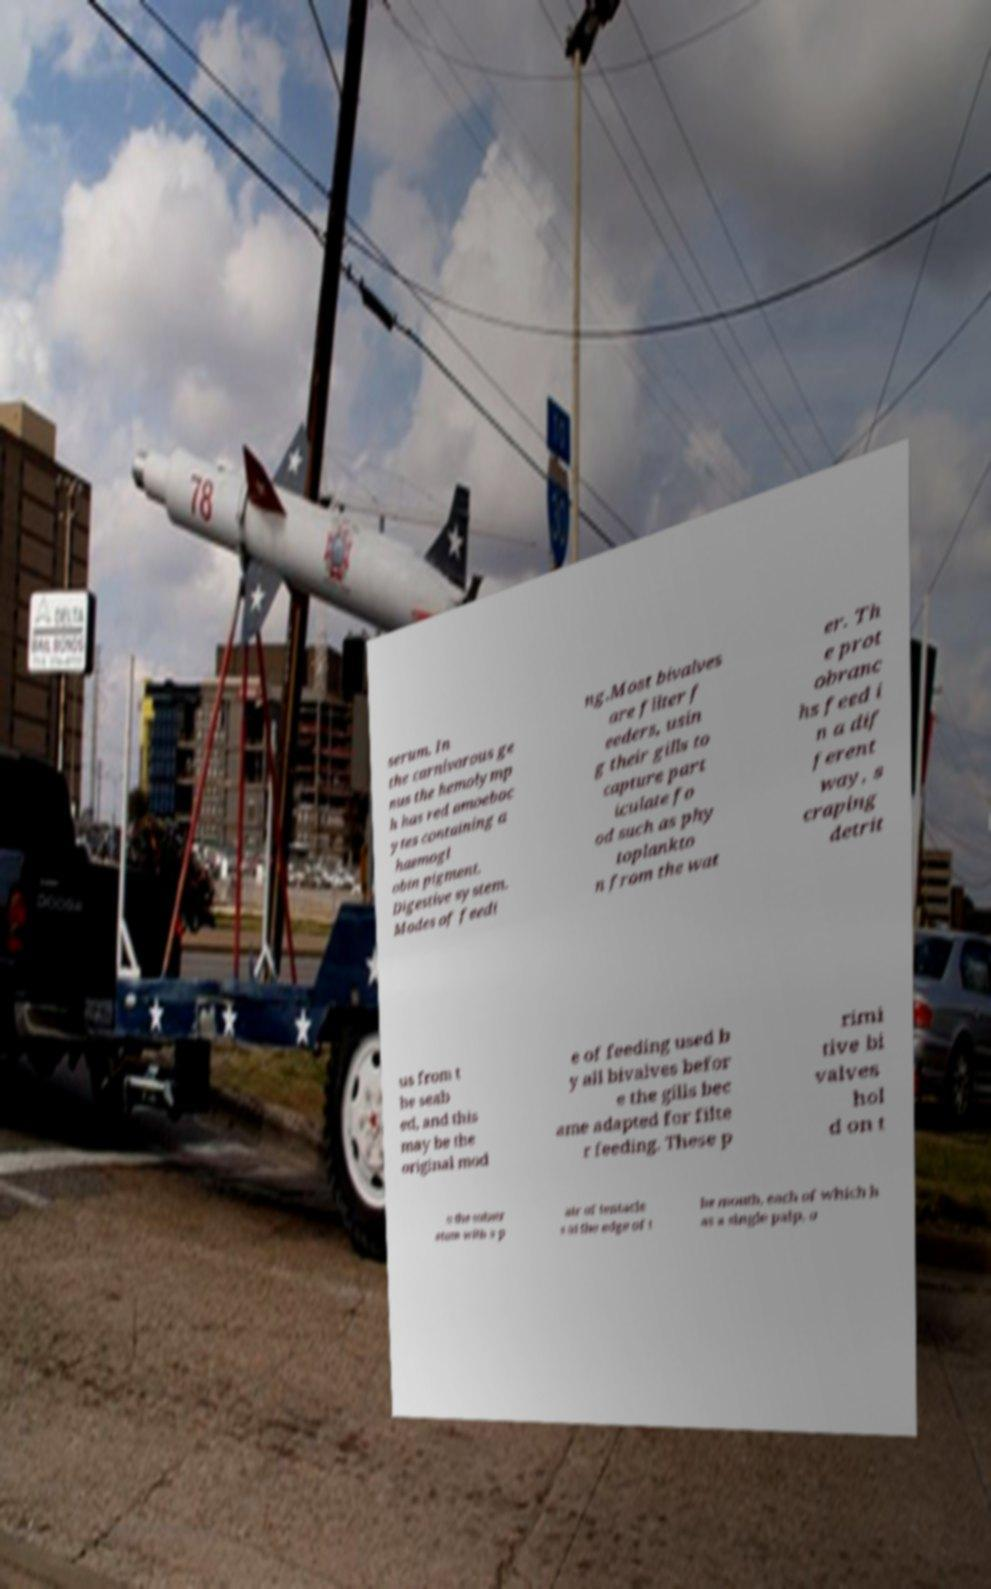Please read and relay the text visible in this image. What does it say? serum. In the carnivorous ge nus the hemolymp h has red amoeboc ytes containing a haemogl obin pigment. Digestive system. Modes of feedi ng.Most bivalves are filter f eeders, usin g their gills to capture part iculate fo od such as phy toplankto n from the wat er. Th e prot obranc hs feed i n a dif ferent way, s craping detrit us from t he seab ed, and this may be the original mod e of feeding used b y all bivalves befor e the gills bec ame adapted for filte r feeding. These p rimi tive bi valves hol d on t o the substr atum with a p air of tentacle s at the edge of t he mouth, each of which h as a single palp, o 